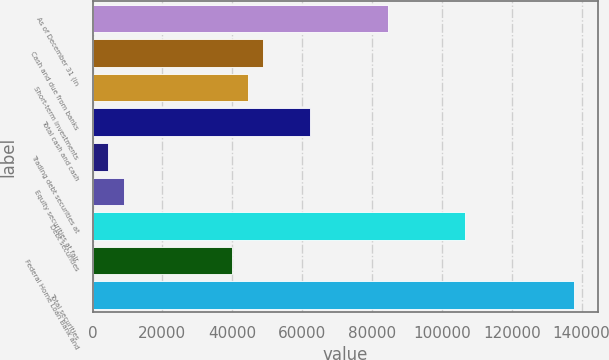Convert chart to OTSL. <chart><loc_0><loc_0><loc_500><loc_500><bar_chart><fcel>As of December 31 (in<fcel>Cash and due from banks<fcel>Short-term investments<fcel>Total cash and cash<fcel>Trading debt securities at<fcel>Equity securities at fair<fcel>Debt securities<fcel>Federal Home Loan Bank and<fcel>Total securities<nl><fcel>84457.5<fcel>48898.3<fcel>44453.4<fcel>62233<fcel>4449.3<fcel>8894.2<fcel>106682<fcel>40008.5<fcel>137796<nl></chart> 